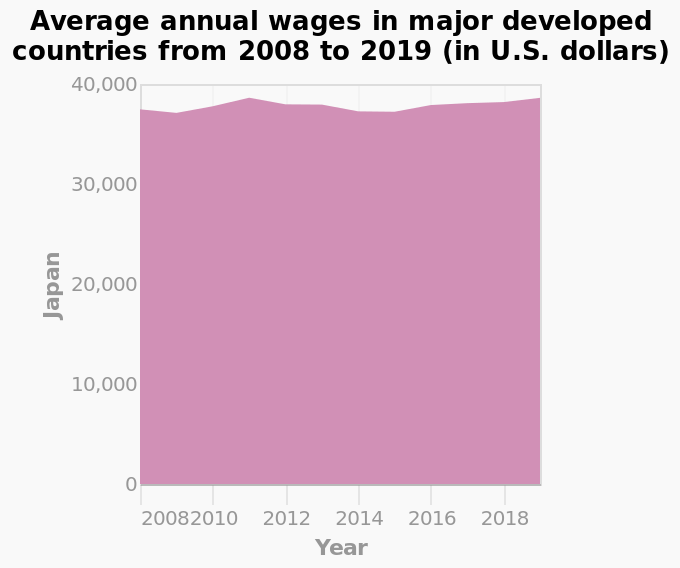<image>
please enumerates aspects of the construction of the chart This area graph is labeled Average annual wages in major developed countries from 2008 to 2019 (in U.S. dollars). A linear scale with a minimum of 0 and a maximum of 40,000 can be seen on the y-axis, marked Japan. Along the x-axis, Year is defined. 